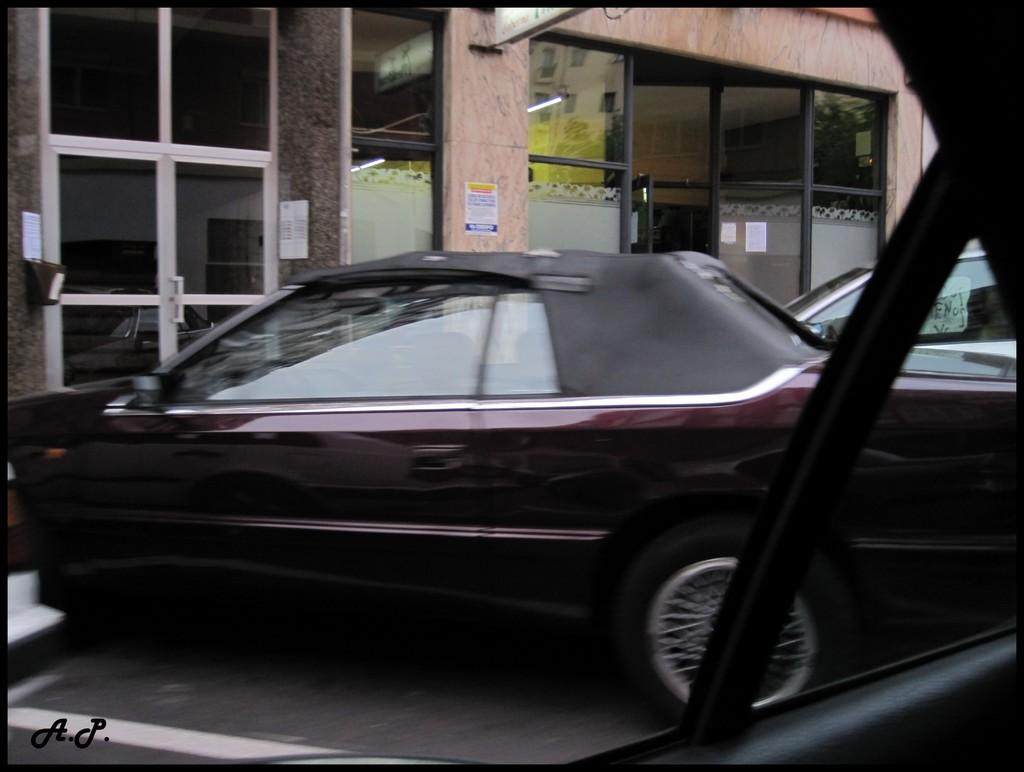What is the perspective of the image? The image is a view from a vehicle. What can be seen in the middle of the image? There is a car in the middle of the image. What is visible in the background of the image? There is a window visible in the background of the image. What type of pleasure can be seen being enjoyed by the passengers in the car? There is no indication of passengers or pleasure being enjoyed in the image; it is a view of a car from a vehicle. Can you see a swing in the image? No, there is no swing present in the image. 